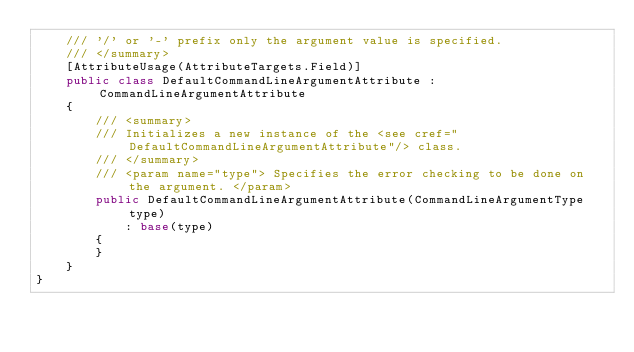<code> <loc_0><loc_0><loc_500><loc_500><_C#_>    /// '/' or '-' prefix only the argument value is specified.
    /// </summary>
    [AttributeUsage(AttributeTargets.Field)]
    public class DefaultCommandLineArgumentAttribute : CommandLineArgumentAttribute
    {
        /// <summary>
        /// Initializes a new instance of the <see cref="DefaultCommandLineArgumentAttribute"/> class.
        /// </summary>
        /// <param name="type"> Specifies the error checking to be done on the argument. </param>
        public DefaultCommandLineArgumentAttribute(CommandLineArgumentType type)
            : base(type)
        {
        }
    }
}
</code> 